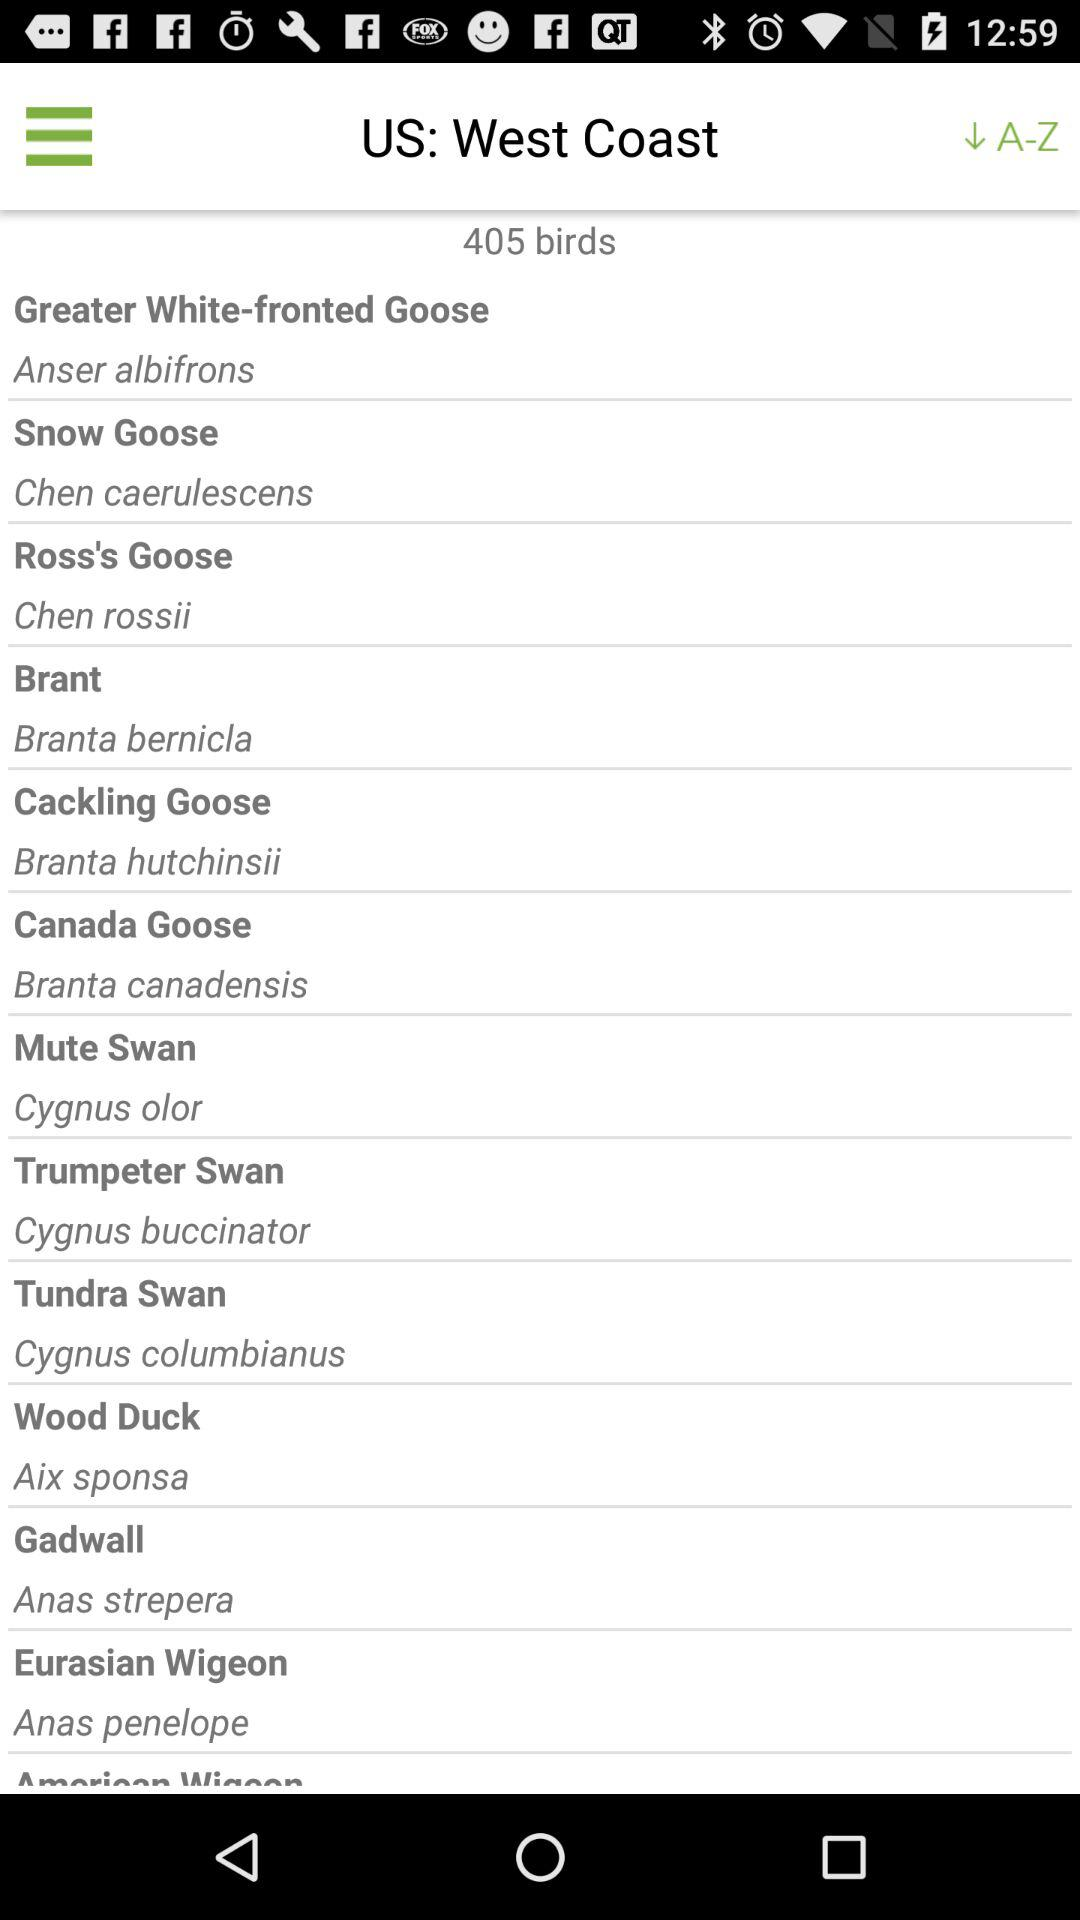How many birds in total are there on the west coast of the US? There are 405 birds. 